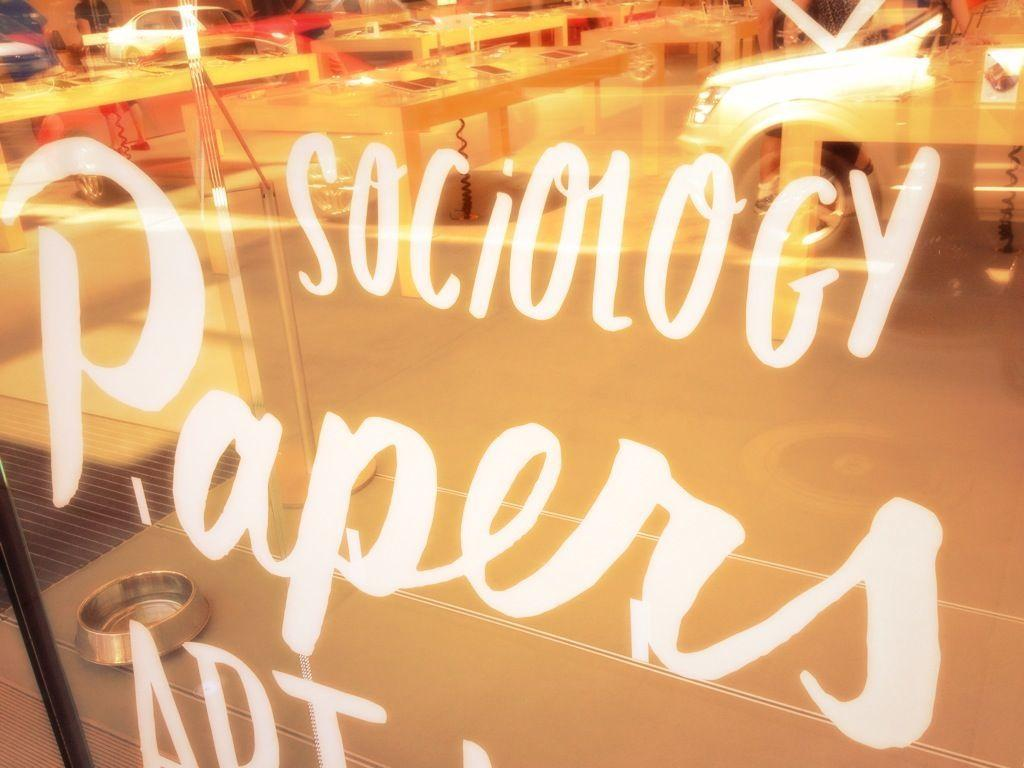What is written or displayed on the glass in the image? There is text on the glass in the image. What can be seen behind the glass? Tables, a bowl, a mat, and a car are visible behind the glass. Can you describe the objects behind the glass in more detail? There are tables, a bowl, a mat, and a car visible behind the glass. How does the branch stretch out towards the car in the image? There is no branch present in the image; it only features text on the glass, tables, a bowl, a mat, and a car. 